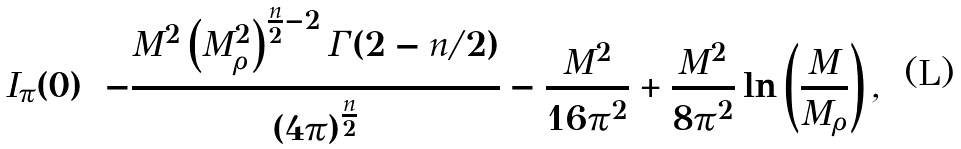Convert formula to latex. <formula><loc_0><loc_0><loc_500><loc_500>I _ { \pi } ( 0 ) = - \frac { M ^ { 2 } \left ( M _ { \rho } ^ { 2 } \right ) ^ { \frac { n } { 2 } - 2 } \Gamma ( 2 - n / 2 ) } { ( 4 \pi ) ^ { \frac { n } { 2 } } } - \frac { M ^ { 2 } } { 1 6 \pi ^ { 2 } } + \frac { M ^ { 2 } } { 8 \pi ^ { 2 } } \ln \left ( \frac { M } { M _ { \rho } } \right ) ,</formula> 